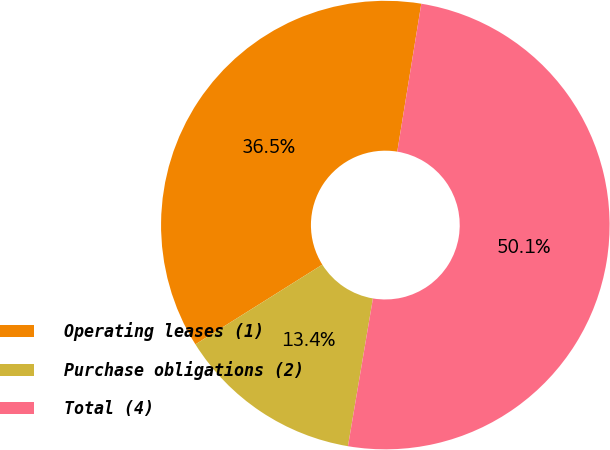Convert chart. <chart><loc_0><loc_0><loc_500><loc_500><pie_chart><fcel>Operating leases (1)<fcel>Purchase obligations (2)<fcel>Total (4)<nl><fcel>36.49%<fcel>13.41%<fcel>50.1%<nl></chart> 